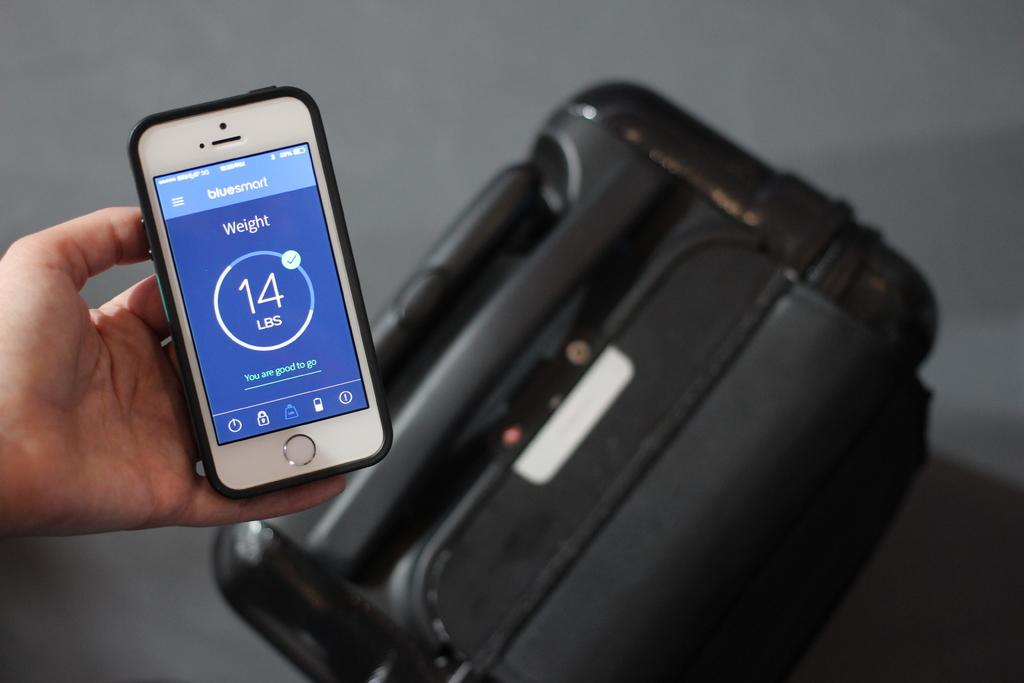<image>
Create a compact narrative representing the image presented. The weight shown on the Iphone is 14 pounds 